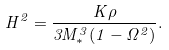Convert formula to latex. <formula><loc_0><loc_0><loc_500><loc_500>H ^ { 2 } = \frac { K \rho } { 3 M _ { * } ^ { 3 } ( 1 - \Omega ^ { 2 } ) } .</formula> 